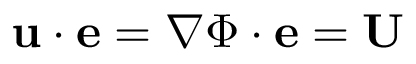<formula> <loc_0><loc_0><loc_500><loc_500>u \cdot e = \nabla { \Phi } \cdot e = U</formula> 